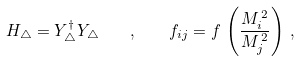Convert formula to latex. <formula><loc_0><loc_0><loc_500><loc_500>H _ { \triangle } = Y ^ { \dag } _ { \triangle } Y _ { \triangle } \quad , \quad f _ { i j } = f \, \left ( \frac { M _ { i } ^ { \, 2 } } { M _ { j } ^ { \, 2 } } \right ) \, ,</formula> 